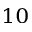<formula> <loc_0><loc_0><loc_500><loc_500>_ { 1 0 }</formula> 